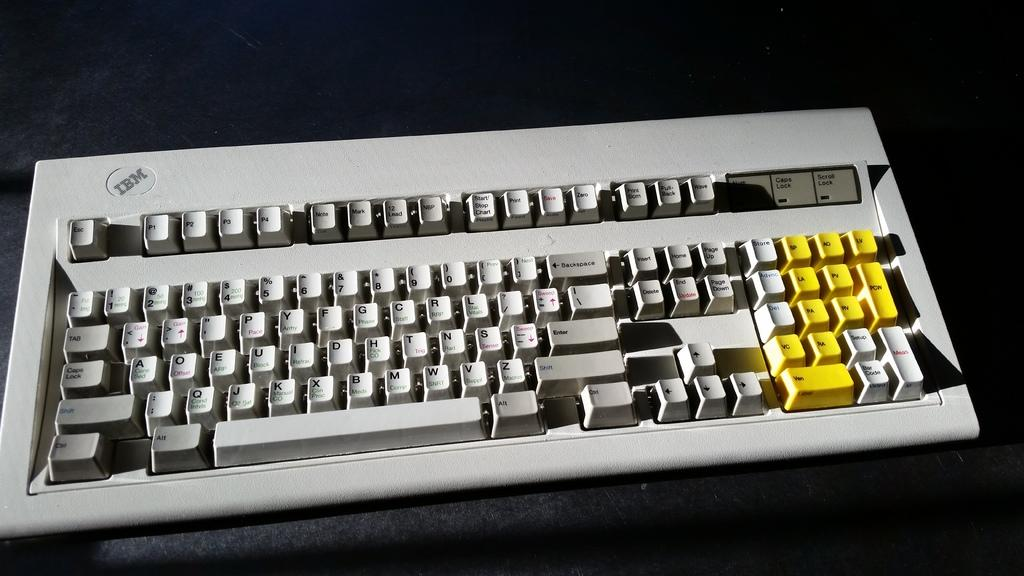<image>
Write a terse but informative summary of the picture. A computer keyboad with all grey keys except for 11 yellow function keys. 